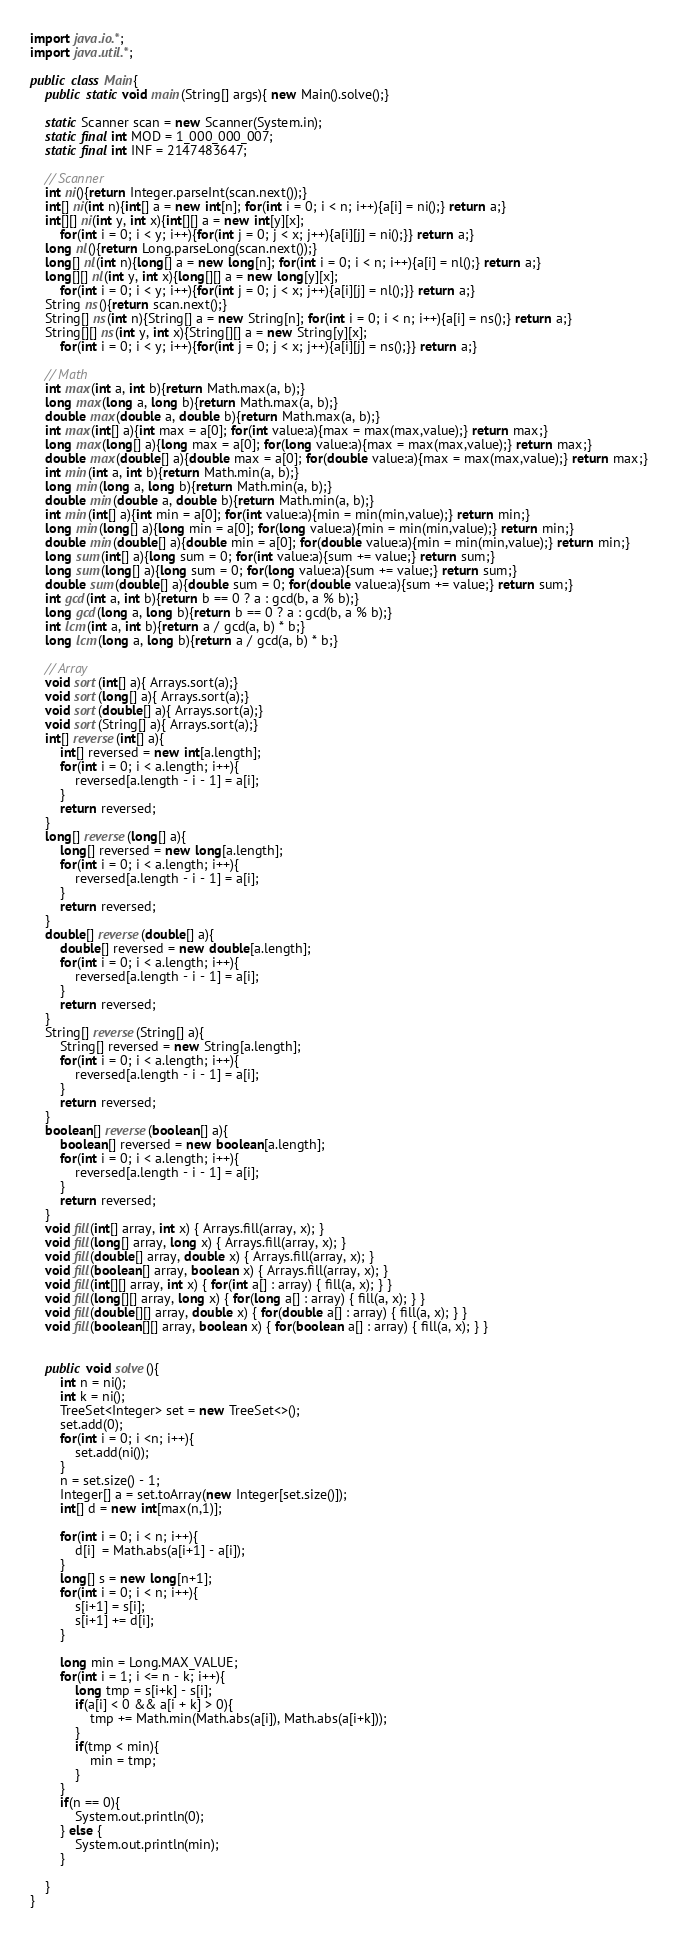<code> <loc_0><loc_0><loc_500><loc_500><_Java_>import java.io.*;
import java.util.*;
 
public class Main{
    public static void main(String[] args){ new Main().solve();}
    
    static Scanner scan = new Scanner(System.in);
    static final int MOD = 1_000_000_007;
    static final int INF = 2147483647;
 
    // Scanner
    int ni(){return Integer.parseInt(scan.next());}
    int[] ni(int n){int[] a = new int[n]; for(int i = 0; i < n; i++){a[i] = ni();} return a;}
    int[][] ni(int y, int x){int[][] a = new int[y][x];
        for(int i = 0; i < y; i++){for(int j = 0; j < x; j++){a[i][j] = ni();}} return a;}
    long nl(){return Long.parseLong(scan.next());}
    long[] nl(int n){long[] a = new long[n]; for(int i = 0; i < n; i++){a[i] = nl();} return a;}
    long[][] nl(int y, int x){long[][] a = new long[y][x];
        for(int i = 0; i < y; i++){for(int j = 0; j < x; j++){a[i][j] = nl();}} return a;}
    String ns(){return scan.next();}
    String[] ns(int n){String[] a = new String[n]; for(int i = 0; i < n; i++){a[i] = ns();} return a;}
    String[][] ns(int y, int x){String[][] a = new String[y][x];
        for(int i = 0; i < y; i++){for(int j = 0; j < x; j++){a[i][j] = ns();}} return a;}
 
    // Math
    int max(int a, int b){return Math.max(a, b);}
    long max(long a, long b){return Math.max(a, b);}
    double max(double a, double b){return Math.max(a, b);}
    int max(int[] a){int max = a[0]; for(int value:a){max = max(max,value);} return max;}
    long max(long[] a){long max = a[0]; for(long value:a){max = max(max,value);} return max;}
    double max(double[] a){double max = a[0]; for(double value:a){max = max(max,value);} return max;}
    int min(int a, int b){return Math.min(a, b);}
    long min(long a, long b){return Math.min(a, b);}
    double min(double a, double b){return Math.min(a, b);}
    int min(int[] a){int min = a[0]; for(int value:a){min = min(min,value);} return min;}
    long min(long[] a){long min = a[0]; for(long value:a){min = min(min,value);} return min;}
    double min(double[] a){double min = a[0]; for(double value:a){min = min(min,value);} return min;}
    long sum(int[] a){long sum = 0; for(int value:a){sum += value;} return sum;}
    long sum(long[] a){long sum = 0; for(long value:a){sum += value;} return sum;}
    double sum(double[] a){double sum = 0; for(double value:a){sum += value;} return sum;}
    int gcd(int a, int b){return b == 0 ? a : gcd(b, a % b);}
    long gcd(long a, long b){return b == 0 ? a : gcd(b, a % b);}
    int lcm(int a, int b){return a / gcd(a, b) * b;}
    long lcm(long a, long b){return a / gcd(a, b) * b;}
 
    // Array
    void sort(int[] a){ Arrays.sort(a);}
    void sort(long[] a){ Arrays.sort(a);}
    void sort(double[] a){ Arrays.sort(a);}
    void sort(String[] a){ Arrays.sort(a);}
    int[] reverse(int[] a){
        int[] reversed = new int[a.length];
        for(int i = 0; i < a.length; i++){
            reversed[a.length - i - 1] = a[i];
        }
        return reversed;
    }
    long[] reverse(long[] a){
        long[] reversed = new long[a.length];
        for(int i = 0; i < a.length; i++){
            reversed[a.length - i - 1] = a[i];
        }
        return reversed;
    }
    double[] reverse(double[] a){
        double[] reversed = new double[a.length];
        for(int i = 0; i < a.length; i++){
            reversed[a.length - i - 1] = a[i];
        }
        return reversed;
    }
    String[] reverse(String[] a){
        String[] reversed = new String[a.length];
        for(int i = 0; i < a.length; i++){
            reversed[a.length - i - 1] = a[i];
        }
        return reversed;
    }
    boolean[] reverse(boolean[] a){
        boolean[] reversed = new boolean[a.length];
        for(int i = 0; i < a.length; i++){
            reversed[a.length - i - 1] = a[i];
        }
        return reversed;
    }
    void fill(int[] array, int x) { Arrays.fill(array, x); }
    void fill(long[] array, long x) { Arrays.fill(array, x); }
    void fill(double[] array, double x) { Arrays.fill(array, x); }
    void fill(boolean[] array, boolean x) { Arrays.fill(array, x); }
    void fill(int[][] array, int x) { for(int a[] : array) { fill(a, x); } }
    void fill(long[][] array, long x) { for(long a[] : array) { fill(a, x); } }
    void fill(double[][] array, double x) { for(double a[] : array) { fill(a, x); } }
    void fill(boolean[][] array, boolean x) { for(boolean a[] : array) { fill(a, x); } }
 
 
    public void solve(){
		int n = ni();
		int k = ni();
		TreeSet<Integer> set = new TreeSet<>();
		set.add(0);
		for(int i = 0; i <n; i++){
			set.add(ni());
		}
		n = set.size() - 1;
		Integer[] a = set.toArray(new Integer[set.size()]);
		int[] d = new int[max(n,1)];
		
		for(int i = 0; i < n; i++){
			d[i]  = Math.abs(a[i+1] - a[i]);
		}
		long[] s = new long[n+1];
		for(int i = 0; i < n; i++){
			s[i+1] = s[i];
			s[i+1] += d[i];
		}
		
		long min = Long.MAX_VALUE;
		for(int i = 1; i <= n - k; i++){
			long tmp = s[i+k] - s[i];
			if(a[i] < 0 && a[i + k] > 0){
				tmp += Math.min(Math.abs(a[i]), Math.abs(a[i+k]));
			}
			if(tmp < min){
				min = tmp;
			}
		}
		if(n == 0){
			System.out.println(0);
		} else {
			System.out.println(min);
		}

    }
}</code> 